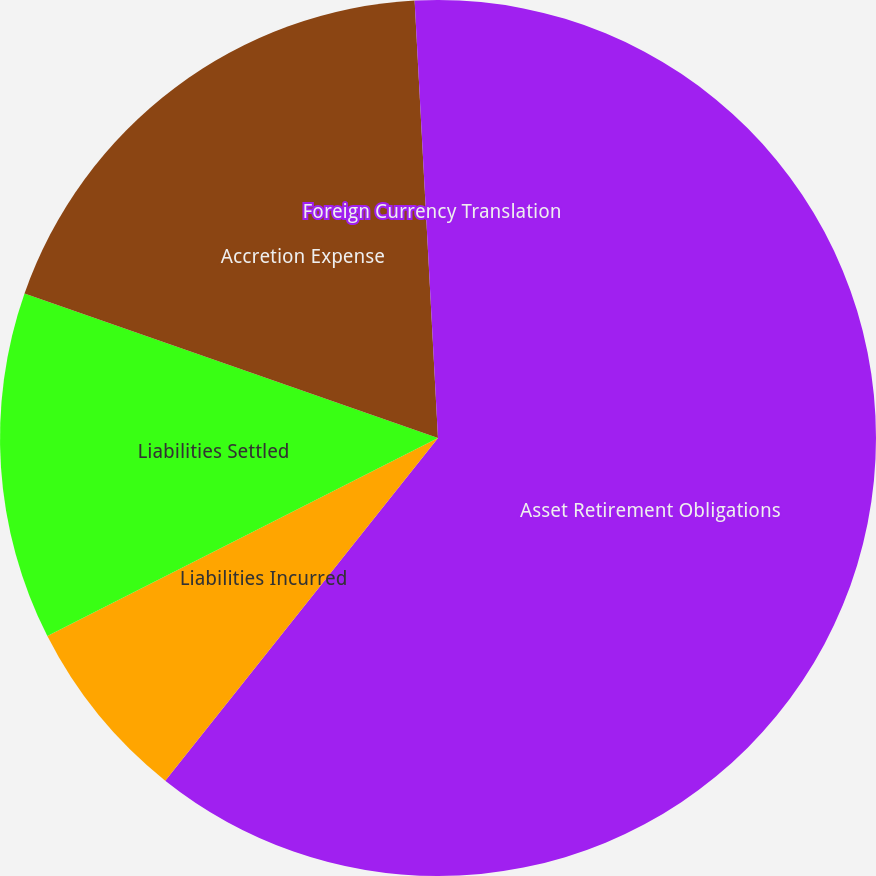Convert chart. <chart><loc_0><loc_0><loc_500><loc_500><pie_chart><fcel>Asset Retirement Obligations<fcel>Liabilities Incurred<fcel>Liabilities Settled<fcel>Accretion Expense<fcel>Foreign Currency Translation<nl><fcel>60.7%<fcel>6.83%<fcel>12.82%<fcel>18.8%<fcel>0.85%<nl></chart> 